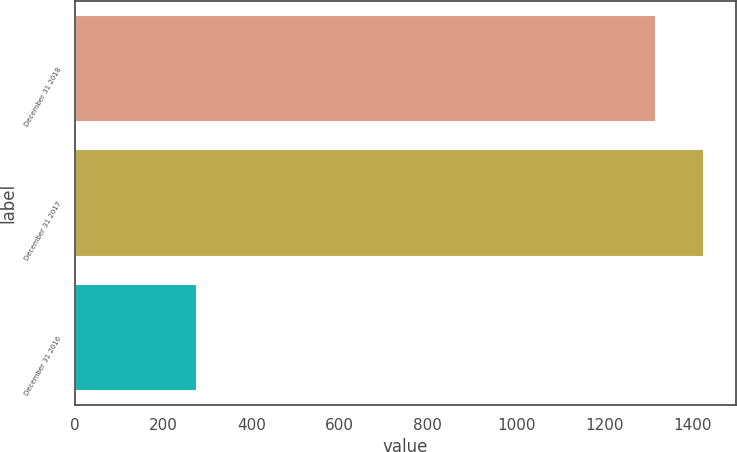Convert chart. <chart><loc_0><loc_0><loc_500><loc_500><bar_chart><fcel>December 31 2018<fcel>December 31 2017<fcel>December 31 2016<nl><fcel>1318<fcel>1427.1<fcel>276<nl></chart> 